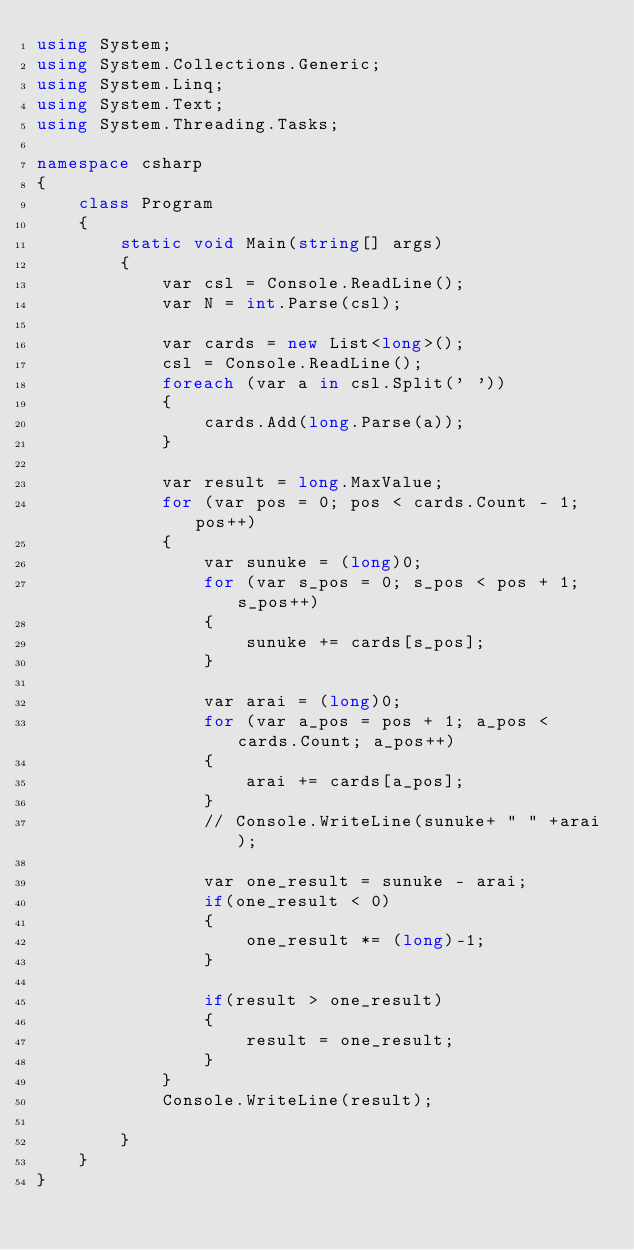<code> <loc_0><loc_0><loc_500><loc_500><_C#_>using System;
using System.Collections.Generic;
using System.Linq;
using System.Text;
using System.Threading.Tasks;

namespace csharp
{
    class Program
    {
        static void Main(string[] args)
        {
            var csl = Console.ReadLine();
            var N = int.Parse(csl);

            var cards = new List<long>();
            csl = Console.ReadLine();
            foreach (var a in csl.Split(' '))
            {
                cards.Add(long.Parse(a));
            }

            var result = long.MaxValue;
            for (var pos = 0; pos < cards.Count - 1; pos++)
            {
                var sunuke = (long)0;
                for (var s_pos = 0; s_pos < pos + 1; s_pos++)
                {
                    sunuke += cards[s_pos];
                }

                var arai = (long)0;
                for (var a_pos = pos + 1; a_pos < cards.Count; a_pos++)
                {
                    arai += cards[a_pos];
                }
                // Console.WriteLine(sunuke+ " " +arai);

                var one_result = sunuke - arai;
                if(one_result < 0)
                {
                    one_result *= (long)-1;
                }

                if(result > one_result)
                {
                    result = one_result;
                }
            }
            Console.WriteLine(result);

        }
    }
}</code> 